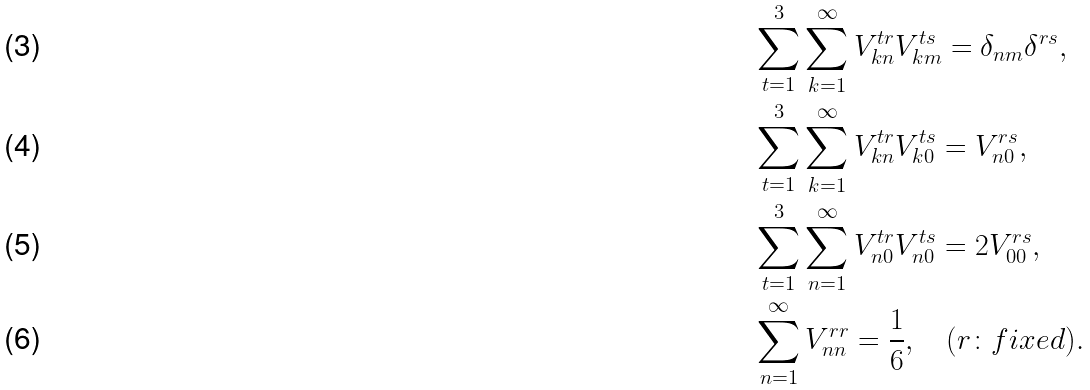<formula> <loc_0><loc_0><loc_500><loc_500>& \sum _ { t = 1 } ^ { 3 } \sum _ { k = 1 } ^ { \infty } V _ { k n } ^ { t r } V _ { k m } ^ { t s } = \delta _ { n m } \delta ^ { r s } , \\ & \sum _ { t = 1 } ^ { 3 } \sum _ { k = 1 } ^ { \infty } V _ { k n } ^ { t r } V _ { k 0 } ^ { t s } = V _ { n 0 } ^ { r s } , \\ & \sum _ { t = 1 } ^ { 3 } \sum _ { n = 1 } ^ { \infty } V _ { n 0 } ^ { t r } V _ { n 0 } ^ { t s } = 2 V _ { 0 0 } ^ { r s } , \\ & \sum _ { n = 1 } ^ { \infty } V _ { n n } ^ { r r } = \frac { 1 } { 6 } , \quad ( r \colon f i x e d ) .</formula> 